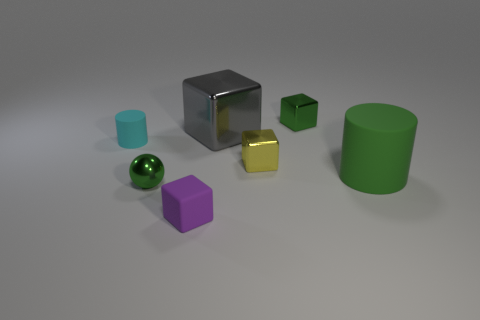Add 2 small green blocks. How many objects exist? 9 Subtract all spheres. How many objects are left? 6 Subtract 1 cyan cylinders. How many objects are left? 6 Subtract all small balls. Subtract all purple cubes. How many objects are left? 5 Add 2 green metallic cubes. How many green metallic cubes are left? 3 Add 4 small spheres. How many small spheres exist? 5 